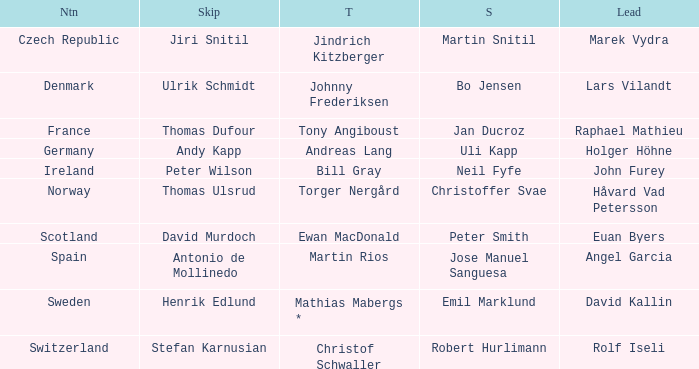Which Skip has a Third of tony angiboust? Thomas Dufour. 